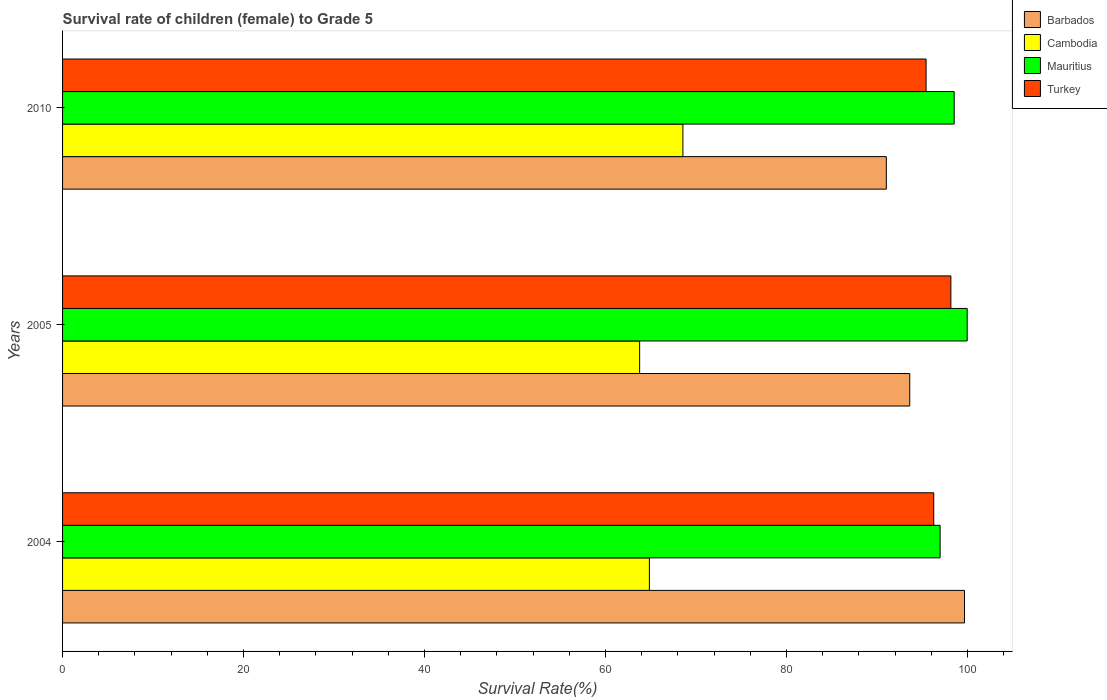How many different coloured bars are there?
Offer a very short reply. 4. Are the number of bars per tick equal to the number of legend labels?
Keep it short and to the point. Yes. Are the number of bars on each tick of the Y-axis equal?
Your answer should be compact. Yes. How many bars are there on the 2nd tick from the top?
Provide a short and direct response. 4. What is the survival rate of female children to grade 5 in Cambodia in 2010?
Offer a very short reply. 68.55. Across all years, what is the maximum survival rate of female children to grade 5 in Turkey?
Your answer should be compact. 98.17. Across all years, what is the minimum survival rate of female children to grade 5 in Cambodia?
Keep it short and to the point. 63.77. In which year was the survival rate of female children to grade 5 in Turkey maximum?
Your answer should be very brief. 2005. What is the total survival rate of female children to grade 5 in Turkey in the graph?
Your response must be concise. 289.87. What is the difference between the survival rate of female children to grade 5 in Turkey in 2005 and that in 2010?
Your answer should be very brief. 2.74. What is the difference between the survival rate of female children to grade 5 in Cambodia in 2004 and the survival rate of female children to grade 5 in Barbados in 2005?
Keep it short and to the point. -28.77. What is the average survival rate of female children to grade 5 in Barbados per year?
Make the answer very short. 94.78. In the year 2010, what is the difference between the survival rate of female children to grade 5 in Cambodia and survival rate of female children to grade 5 in Barbados?
Offer a terse response. -22.48. What is the ratio of the survival rate of female children to grade 5 in Barbados in 2004 to that in 2010?
Give a very brief answer. 1.09. Is the difference between the survival rate of female children to grade 5 in Cambodia in 2005 and 2010 greater than the difference between the survival rate of female children to grade 5 in Barbados in 2005 and 2010?
Keep it short and to the point. No. What is the difference between the highest and the second highest survival rate of female children to grade 5 in Cambodia?
Provide a succinct answer. 3.7. What is the difference between the highest and the lowest survival rate of female children to grade 5 in Mauritius?
Give a very brief answer. 2.99. Is the sum of the survival rate of female children to grade 5 in Barbados in 2005 and 2010 greater than the maximum survival rate of female children to grade 5 in Turkey across all years?
Your response must be concise. Yes. What does the 4th bar from the top in 2005 represents?
Offer a very short reply. Barbados. What does the 1st bar from the bottom in 2004 represents?
Your answer should be compact. Barbados. Is it the case that in every year, the sum of the survival rate of female children to grade 5 in Mauritius and survival rate of female children to grade 5 in Turkey is greater than the survival rate of female children to grade 5 in Barbados?
Offer a very short reply. Yes. Are all the bars in the graph horizontal?
Your answer should be very brief. Yes. How many years are there in the graph?
Provide a short and direct response. 3. Where does the legend appear in the graph?
Provide a short and direct response. Top right. How many legend labels are there?
Your answer should be compact. 4. How are the legend labels stacked?
Give a very brief answer. Vertical. What is the title of the graph?
Provide a short and direct response. Survival rate of children (female) to Grade 5. Does "Dominica" appear as one of the legend labels in the graph?
Provide a short and direct response. No. What is the label or title of the X-axis?
Your answer should be very brief. Survival Rate(%). What is the Survival Rate(%) of Barbados in 2004?
Provide a short and direct response. 99.67. What is the Survival Rate(%) of Cambodia in 2004?
Your answer should be very brief. 64.85. What is the Survival Rate(%) of Mauritius in 2004?
Provide a short and direct response. 96.98. What is the Survival Rate(%) of Turkey in 2004?
Give a very brief answer. 96.27. What is the Survival Rate(%) in Barbados in 2005?
Your response must be concise. 93.62. What is the Survival Rate(%) of Cambodia in 2005?
Your answer should be very brief. 63.77. What is the Survival Rate(%) of Mauritius in 2005?
Provide a short and direct response. 99.97. What is the Survival Rate(%) in Turkey in 2005?
Provide a short and direct response. 98.17. What is the Survival Rate(%) in Barbados in 2010?
Offer a very short reply. 91.04. What is the Survival Rate(%) of Cambodia in 2010?
Give a very brief answer. 68.55. What is the Survival Rate(%) of Mauritius in 2010?
Provide a succinct answer. 98.53. What is the Survival Rate(%) of Turkey in 2010?
Ensure brevity in your answer.  95.43. Across all years, what is the maximum Survival Rate(%) in Barbados?
Give a very brief answer. 99.67. Across all years, what is the maximum Survival Rate(%) of Cambodia?
Your answer should be very brief. 68.55. Across all years, what is the maximum Survival Rate(%) of Mauritius?
Offer a terse response. 99.97. Across all years, what is the maximum Survival Rate(%) of Turkey?
Ensure brevity in your answer.  98.17. Across all years, what is the minimum Survival Rate(%) of Barbados?
Offer a terse response. 91.04. Across all years, what is the minimum Survival Rate(%) in Cambodia?
Give a very brief answer. 63.77. Across all years, what is the minimum Survival Rate(%) in Mauritius?
Provide a succinct answer. 96.98. Across all years, what is the minimum Survival Rate(%) of Turkey?
Give a very brief answer. 95.43. What is the total Survival Rate(%) of Barbados in the graph?
Your answer should be compact. 284.33. What is the total Survival Rate(%) in Cambodia in the graph?
Offer a very short reply. 197.18. What is the total Survival Rate(%) of Mauritius in the graph?
Keep it short and to the point. 295.48. What is the total Survival Rate(%) of Turkey in the graph?
Offer a very short reply. 289.87. What is the difference between the Survival Rate(%) in Barbados in 2004 and that in 2005?
Keep it short and to the point. 6.05. What is the difference between the Survival Rate(%) in Cambodia in 2004 and that in 2005?
Your response must be concise. 1.08. What is the difference between the Survival Rate(%) of Mauritius in 2004 and that in 2005?
Make the answer very short. -2.99. What is the difference between the Survival Rate(%) in Turkey in 2004 and that in 2005?
Give a very brief answer. -1.89. What is the difference between the Survival Rate(%) of Barbados in 2004 and that in 2010?
Your answer should be very brief. 8.64. What is the difference between the Survival Rate(%) in Cambodia in 2004 and that in 2010?
Give a very brief answer. -3.7. What is the difference between the Survival Rate(%) in Mauritius in 2004 and that in 2010?
Give a very brief answer. -1.55. What is the difference between the Survival Rate(%) in Turkey in 2004 and that in 2010?
Give a very brief answer. 0.85. What is the difference between the Survival Rate(%) in Barbados in 2005 and that in 2010?
Provide a succinct answer. 2.58. What is the difference between the Survival Rate(%) of Cambodia in 2005 and that in 2010?
Your answer should be very brief. -4.78. What is the difference between the Survival Rate(%) in Mauritius in 2005 and that in 2010?
Provide a succinct answer. 1.44. What is the difference between the Survival Rate(%) in Turkey in 2005 and that in 2010?
Provide a short and direct response. 2.74. What is the difference between the Survival Rate(%) in Barbados in 2004 and the Survival Rate(%) in Cambodia in 2005?
Provide a succinct answer. 35.9. What is the difference between the Survival Rate(%) of Barbados in 2004 and the Survival Rate(%) of Mauritius in 2005?
Keep it short and to the point. -0.3. What is the difference between the Survival Rate(%) in Barbados in 2004 and the Survival Rate(%) in Turkey in 2005?
Offer a very short reply. 1.51. What is the difference between the Survival Rate(%) in Cambodia in 2004 and the Survival Rate(%) in Mauritius in 2005?
Your answer should be very brief. -35.12. What is the difference between the Survival Rate(%) of Cambodia in 2004 and the Survival Rate(%) of Turkey in 2005?
Keep it short and to the point. -33.32. What is the difference between the Survival Rate(%) in Mauritius in 2004 and the Survival Rate(%) in Turkey in 2005?
Give a very brief answer. -1.19. What is the difference between the Survival Rate(%) in Barbados in 2004 and the Survival Rate(%) in Cambodia in 2010?
Provide a succinct answer. 31.12. What is the difference between the Survival Rate(%) of Barbados in 2004 and the Survival Rate(%) of Mauritius in 2010?
Your answer should be very brief. 1.14. What is the difference between the Survival Rate(%) of Barbados in 2004 and the Survival Rate(%) of Turkey in 2010?
Your answer should be very brief. 4.25. What is the difference between the Survival Rate(%) in Cambodia in 2004 and the Survival Rate(%) in Mauritius in 2010?
Your response must be concise. -33.68. What is the difference between the Survival Rate(%) of Cambodia in 2004 and the Survival Rate(%) of Turkey in 2010?
Provide a succinct answer. -30.58. What is the difference between the Survival Rate(%) in Mauritius in 2004 and the Survival Rate(%) in Turkey in 2010?
Give a very brief answer. 1.55. What is the difference between the Survival Rate(%) in Barbados in 2005 and the Survival Rate(%) in Cambodia in 2010?
Give a very brief answer. 25.07. What is the difference between the Survival Rate(%) of Barbados in 2005 and the Survival Rate(%) of Mauritius in 2010?
Offer a very short reply. -4.91. What is the difference between the Survival Rate(%) in Barbados in 2005 and the Survival Rate(%) in Turkey in 2010?
Give a very brief answer. -1.81. What is the difference between the Survival Rate(%) in Cambodia in 2005 and the Survival Rate(%) in Mauritius in 2010?
Keep it short and to the point. -34.76. What is the difference between the Survival Rate(%) of Cambodia in 2005 and the Survival Rate(%) of Turkey in 2010?
Give a very brief answer. -31.66. What is the difference between the Survival Rate(%) of Mauritius in 2005 and the Survival Rate(%) of Turkey in 2010?
Your answer should be very brief. 4.54. What is the average Survival Rate(%) of Barbados per year?
Ensure brevity in your answer.  94.78. What is the average Survival Rate(%) in Cambodia per year?
Provide a short and direct response. 65.73. What is the average Survival Rate(%) of Mauritius per year?
Your response must be concise. 98.49. What is the average Survival Rate(%) in Turkey per year?
Your answer should be very brief. 96.62. In the year 2004, what is the difference between the Survival Rate(%) in Barbados and Survival Rate(%) in Cambodia?
Give a very brief answer. 34.82. In the year 2004, what is the difference between the Survival Rate(%) of Barbados and Survival Rate(%) of Mauritius?
Your response must be concise. 2.69. In the year 2004, what is the difference between the Survival Rate(%) of Barbados and Survival Rate(%) of Turkey?
Provide a succinct answer. 3.4. In the year 2004, what is the difference between the Survival Rate(%) of Cambodia and Survival Rate(%) of Mauritius?
Offer a very short reply. -32.13. In the year 2004, what is the difference between the Survival Rate(%) of Cambodia and Survival Rate(%) of Turkey?
Your answer should be very brief. -31.42. In the year 2004, what is the difference between the Survival Rate(%) in Mauritius and Survival Rate(%) in Turkey?
Offer a very short reply. 0.71. In the year 2005, what is the difference between the Survival Rate(%) of Barbados and Survival Rate(%) of Cambodia?
Keep it short and to the point. 29.85. In the year 2005, what is the difference between the Survival Rate(%) of Barbados and Survival Rate(%) of Mauritius?
Offer a very short reply. -6.35. In the year 2005, what is the difference between the Survival Rate(%) in Barbados and Survival Rate(%) in Turkey?
Provide a short and direct response. -4.55. In the year 2005, what is the difference between the Survival Rate(%) in Cambodia and Survival Rate(%) in Mauritius?
Your response must be concise. -36.2. In the year 2005, what is the difference between the Survival Rate(%) of Cambodia and Survival Rate(%) of Turkey?
Ensure brevity in your answer.  -34.4. In the year 2005, what is the difference between the Survival Rate(%) of Mauritius and Survival Rate(%) of Turkey?
Your answer should be compact. 1.8. In the year 2010, what is the difference between the Survival Rate(%) of Barbados and Survival Rate(%) of Cambodia?
Offer a terse response. 22.48. In the year 2010, what is the difference between the Survival Rate(%) in Barbados and Survival Rate(%) in Mauritius?
Keep it short and to the point. -7.5. In the year 2010, what is the difference between the Survival Rate(%) in Barbados and Survival Rate(%) in Turkey?
Your answer should be compact. -4.39. In the year 2010, what is the difference between the Survival Rate(%) in Cambodia and Survival Rate(%) in Mauritius?
Your answer should be very brief. -29.98. In the year 2010, what is the difference between the Survival Rate(%) in Cambodia and Survival Rate(%) in Turkey?
Make the answer very short. -26.87. In the year 2010, what is the difference between the Survival Rate(%) of Mauritius and Survival Rate(%) of Turkey?
Your answer should be very brief. 3.11. What is the ratio of the Survival Rate(%) of Barbados in 2004 to that in 2005?
Offer a terse response. 1.06. What is the ratio of the Survival Rate(%) of Cambodia in 2004 to that in 2005?
Keep it short and to the point. 1.02. What is the ratio of the Survival Rate(%) in Mauritius in 2004 to that in 2005?
Make the answer very short. 0.97. What is the ratio of the Survival Rate(%) in Turkey in 2004 to that in 2005?
Make the answer very short. 0.98. What is the ratio of the Survival Rate(%) in Barbados in 2004 to that in 2010?
Your response must be concise. 1.09. What is the ratio of the Survival Rate(%) in Cambodia in 2004 to that in 2010?
Give a very brief answer. 0.95. What is the ratio of the Survival Rate(%) of Mauritius in 2004 to that in 2010?
Your response must be concise. 0.98. What is the ratio of the Survival Rate(%) in Turkey in 2004 to that in 2010?
Keep it short and to the point. 1.01. What is the ratio of the Survival Rate(%) of Barbados in 2005 to that in 2010?
Keep it short and to the point. 1.03. What is the ratio of the Survival Rate(%) in Cambodia in 2005 to that in 2010?
Provide a succinct answer. 0.93. What is the ratio of the Survival Rate(%) in Mauritius in 2005 to that in 2010?
Give a very brief answer. 1.01. What is the ratio of the Survival Rate(%) in Turkey in 2005 to that in 2010?
Provide a succinct answer. 1.03. What is the difference between the highest and the second highest Survival Rate(%) in Barbados?
Make the answer very short. 6.05. What is the difference between the highest and the second highest Survival Rate(%) of Cambodia?
Your answer should be compact. 3.7. What is the difference between the highest and the second highest Survival Rate(%) of Mauritius?
Your response must be concise. 1.44. What is the difference between the highest and the second highest Survival Rate(%) of Turkey?
Offer a very short reply. 1.89. What is the difference between the highest and the lowest Survival Rate(%) in Barbados?
Offer a very short reply. 8.64. What is the difference between the highest and the lowest Survival Rate(%) in Cambodia?
Offer a terse response. 4.78. What is the difference between the highest and the lowest Survival Rate(%) of Mauritius?
Your answer should be very brief. 2.99. What is the difference between the highest and the lowest Survival Rate(%) of Turkey?
Your answer should be compact. 2.74. 